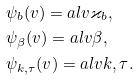Convert formula to latex. <formula><loc_0><loc_0><loc_500><loc_500>& \psi _ { b } ( v ) = a l { v } { \varkappa _ { b } } , \\ & \psi _ { \beta } ( v ) = a l { v } { \beta } , \\ & \psi _ { k , \tau } ( v ) = a l { v } { k , \tau } .</formula> 